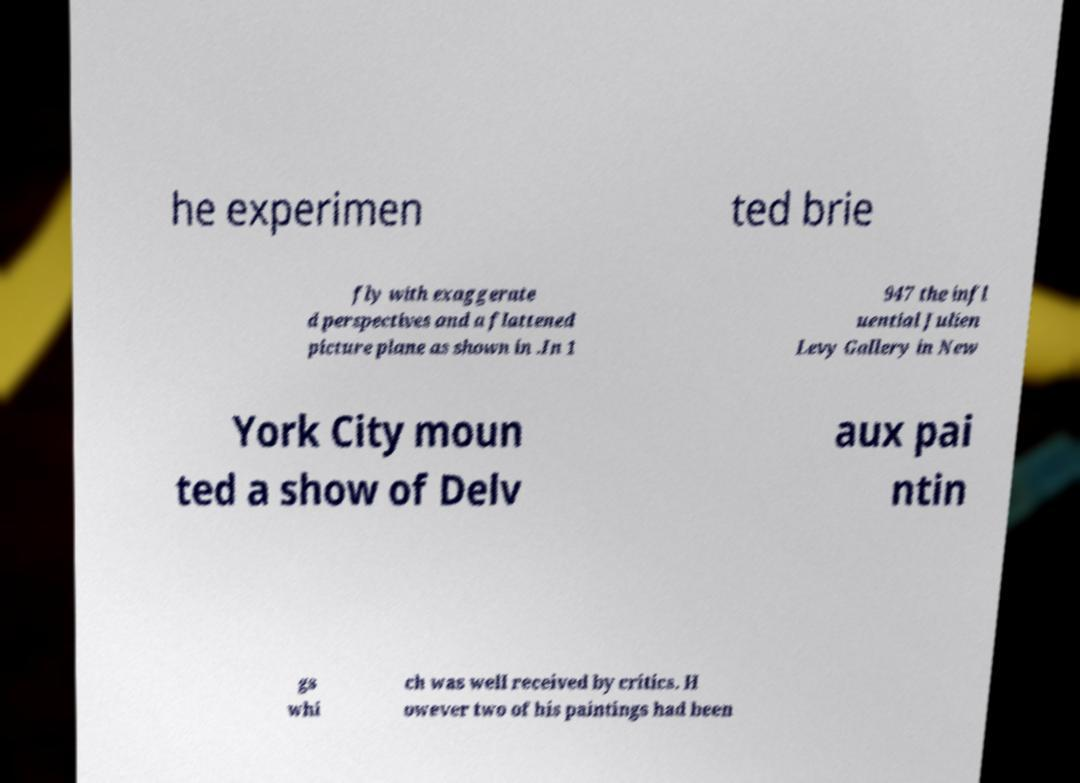For documentation purposes, I need the text within this image transcribed. Could you provide that? he experimen ted brie fly with exaggerate d perspectives and a flattened picture plane as shown in .In 1 947 the infl uential Julien Levy Gallery in New York City moun ted a show of Delv aux pai ntin gs whi ch was well received by critics. H owever two of his paintings had been 